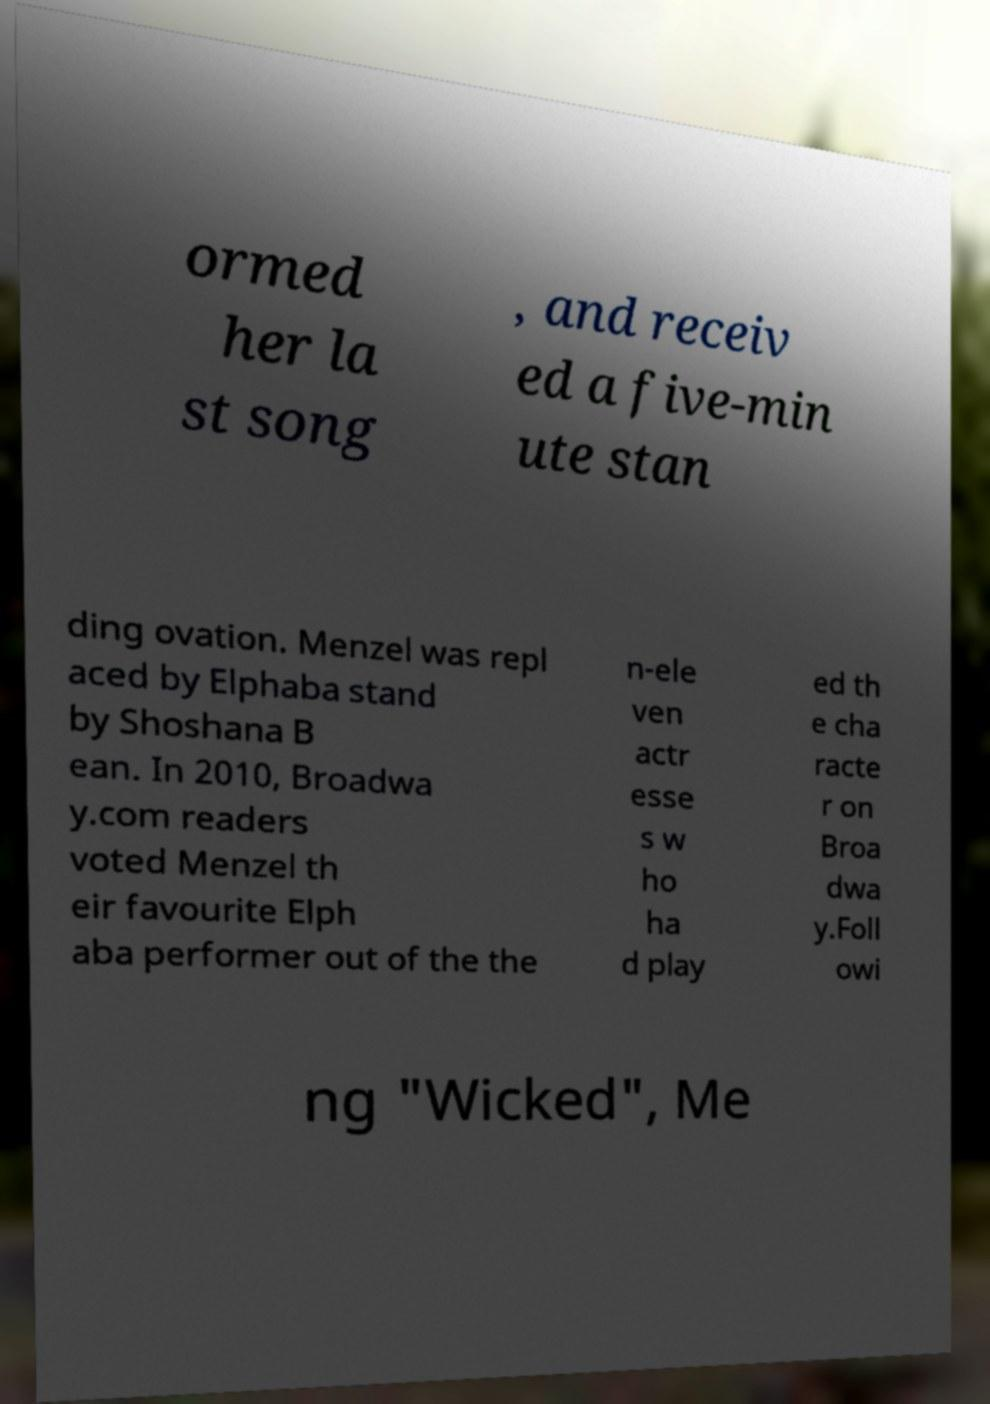What messages or text are displayed in this image? I need them in a readable, typed format. ormed her la st song , and receiv ed a five-min ute stan ding ovation. Menzel was repl aced by Elphaba stand by Shoshana B ean. In 2010, Broadwa y.com readers voted Menzel th eir favourite Elph aba performer out of the the n-ele ven actr esse s w ho ha d play ed th e cha racte r on Broa dwa y.Foll owi ng "Wicked", Me 